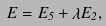<formula> <loc_0><loc_0><loc_500><loc_500>E = E _ { 5 } + \lambda E _ { 2 } ,</formula> 